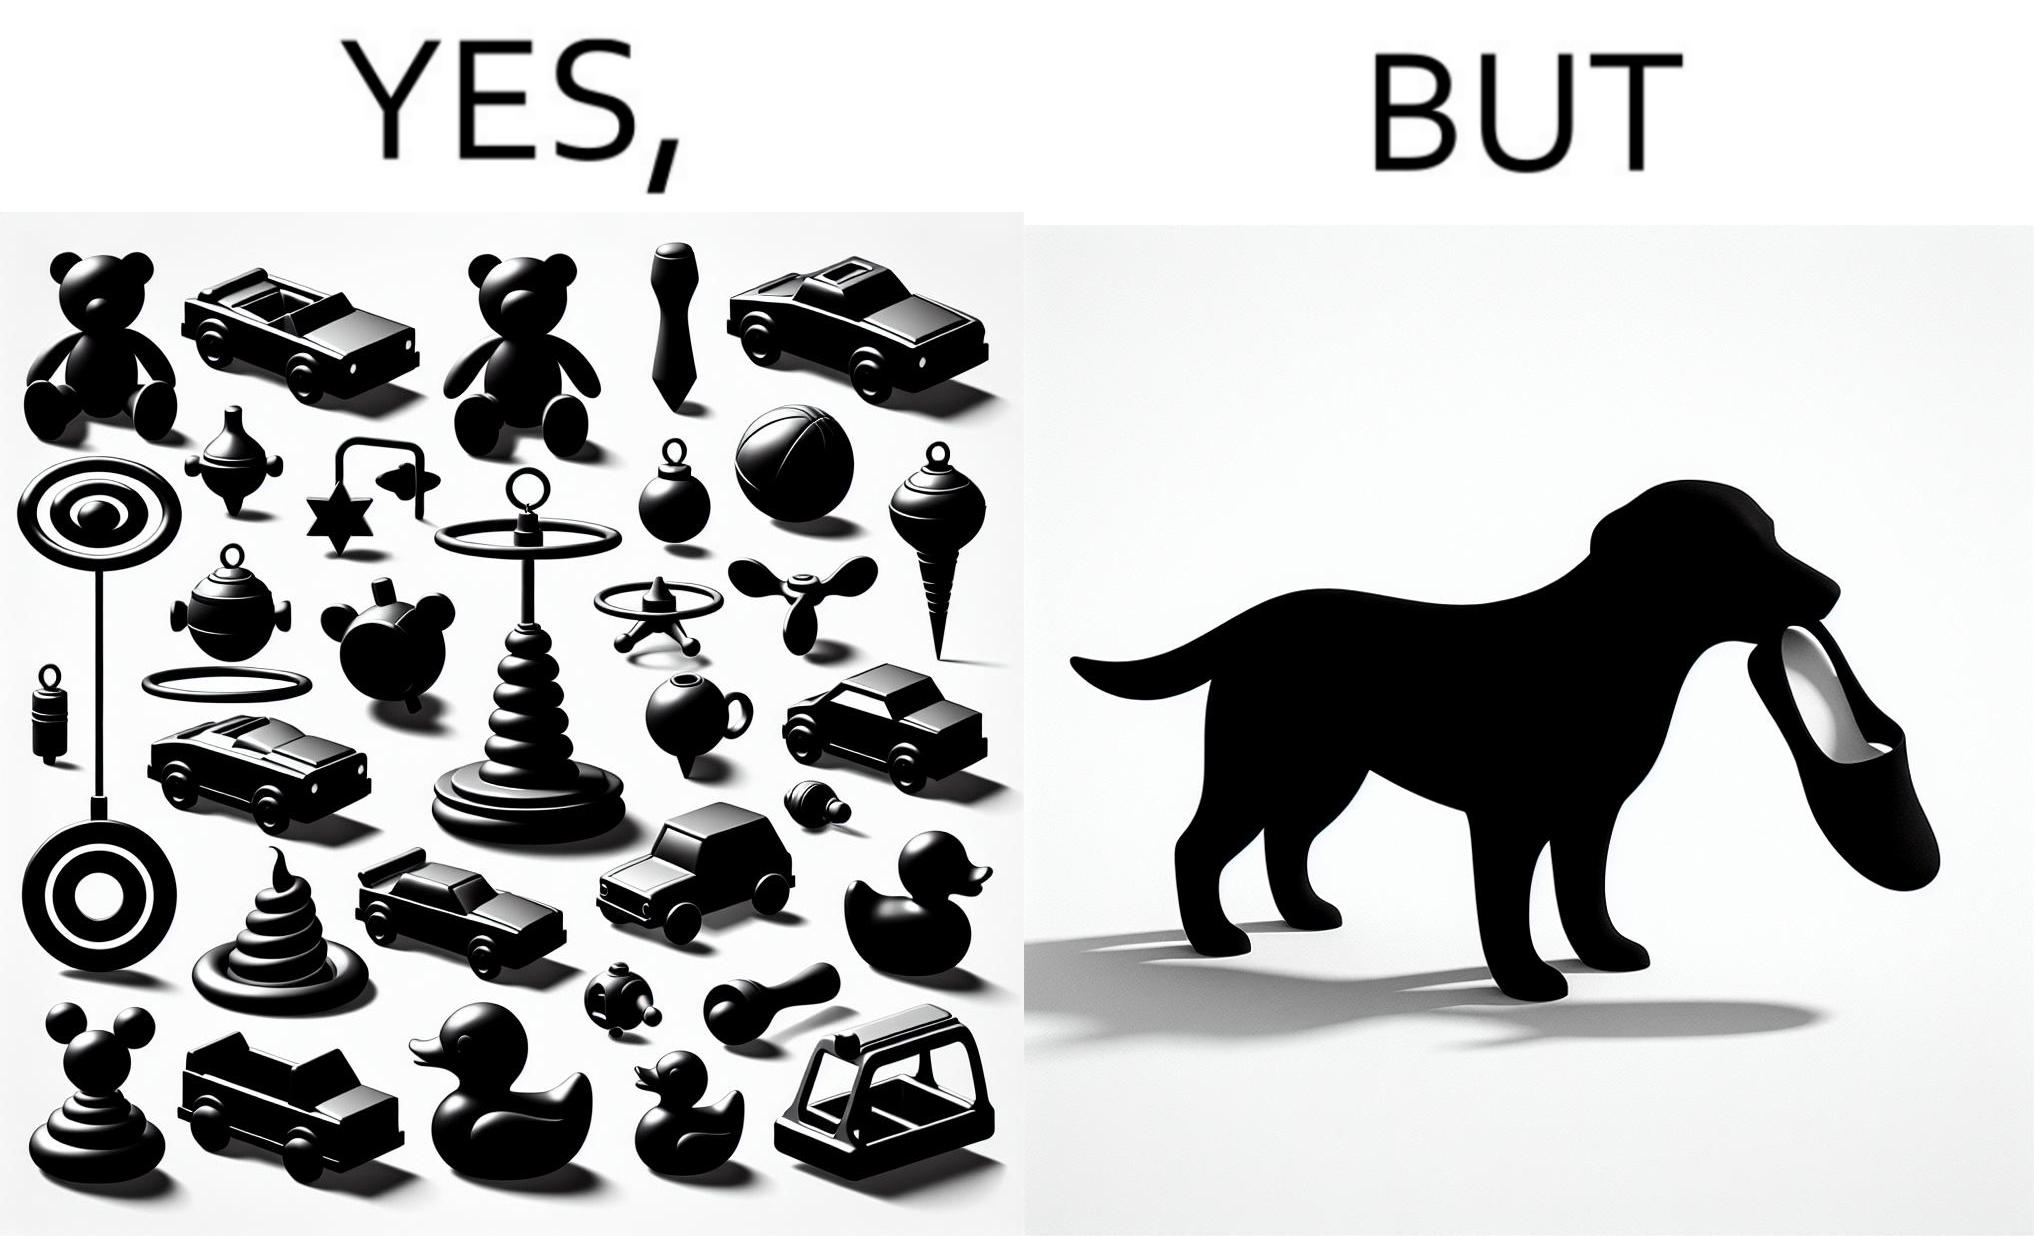Describe what you see in this image. the irony is that dog owners buy loads of toys for their dog but the dog's favourite toy is the owner's slippers 